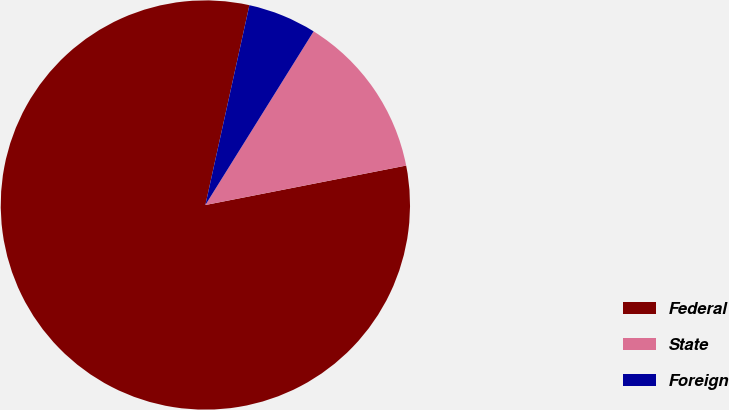Convert chart to OTSL. <chart><loc_0><loc_0><loc_500><loc_500><pie_chart><fcel>Federal<fcel>State<fcel>Foreign<nl><fcel>81.54%<fcel>13.04%<fcel>5.42%<nl></chart> 